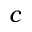<formula> <loc_0><loc_0><loc_500><loc_500>c</formula> 